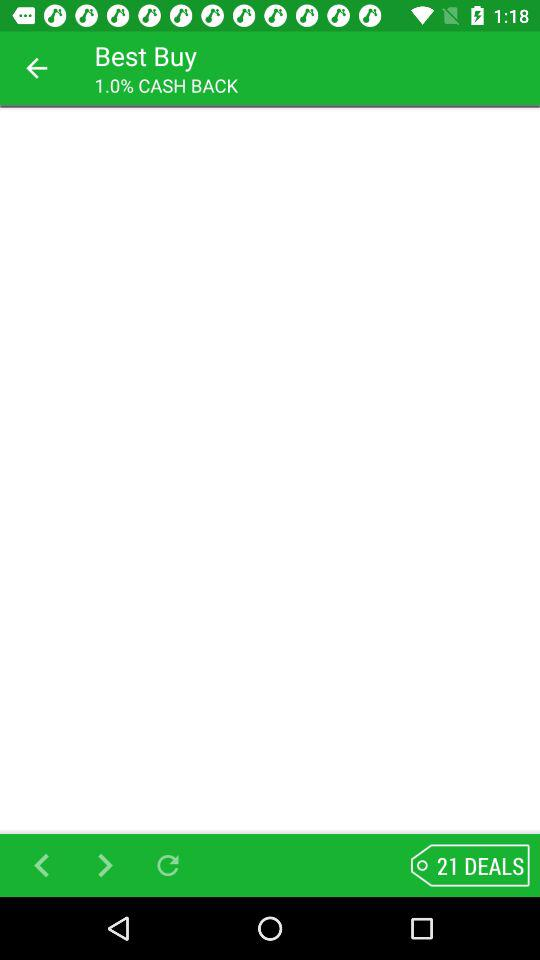What is the percentage of cashback? The cashback is 1%. 